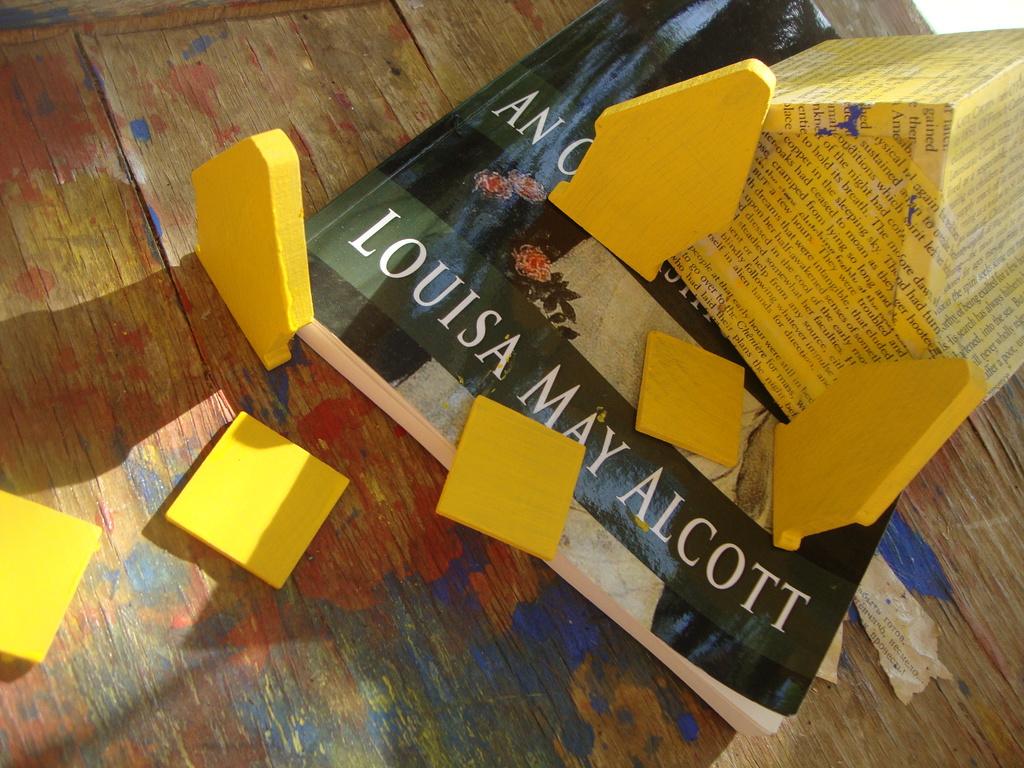What is the name of the author?
Offer a very short reply. Louisa may alcott. What is the first word in the title?
Give a very brief answer. An. 